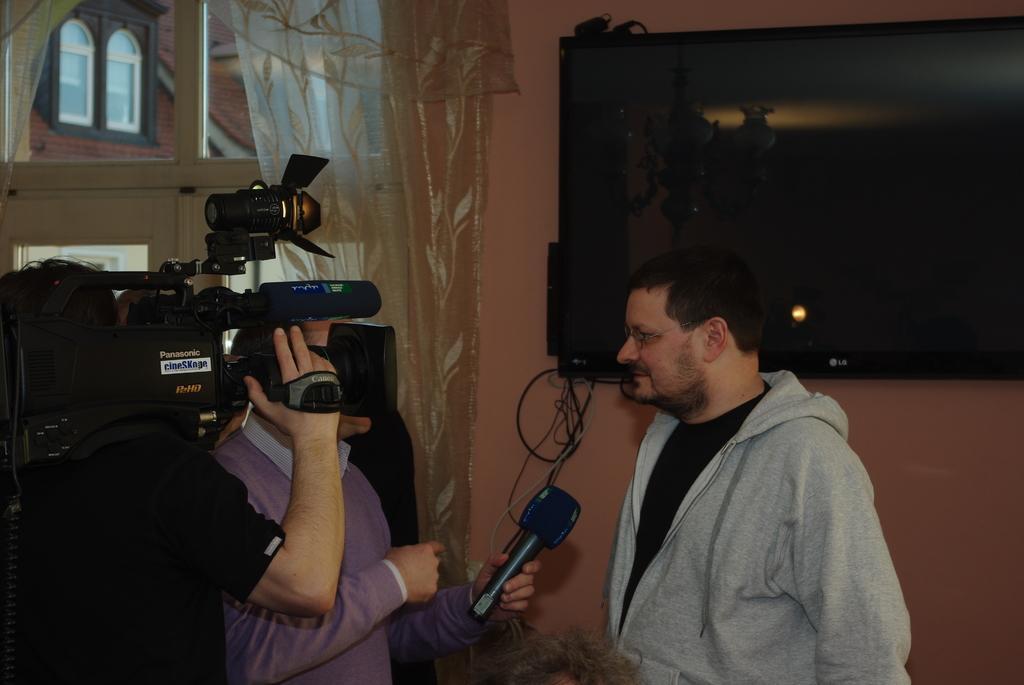How would you summarize this image in a sentence or two? The picture is taken inside a room. In the right one person wearing grey jacket is standing. In the left a person wearing black t-shirt is holding a camera beside him one person wearing violet sweater is holding one mic. A tv is mounted on the wall. In the background there are curtains and window. 